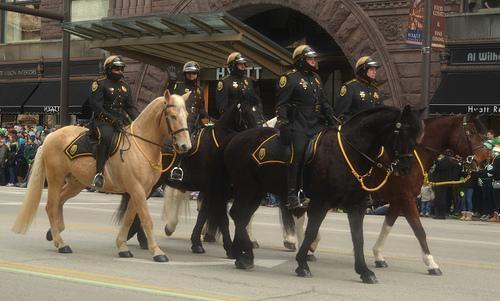How many police officers are visible riding horses?
Give a very brief answer. 5. How many of the four horses are blonde?
Give a very brief answer. 1. How many horses are black?
Give a very brief answer. 2. How many police riders are wearing helmets?
Give a very brief answer. 5. 